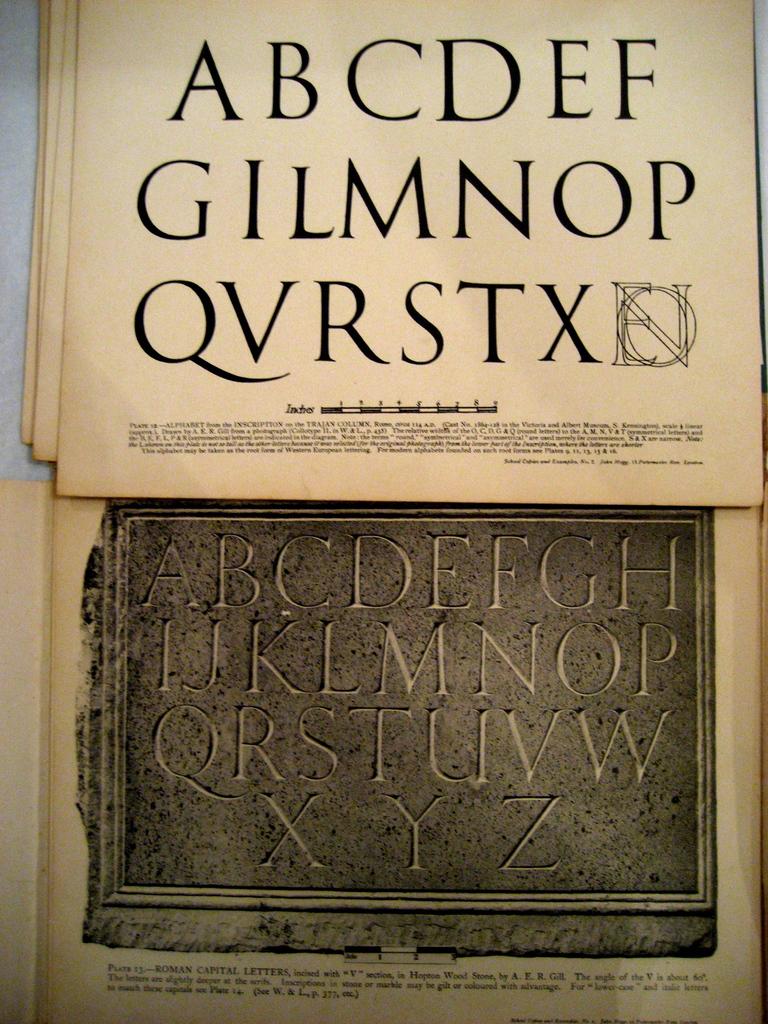What are the last 3 letters on the bottom?
Ensure brevity in your answer.  Xyz. 